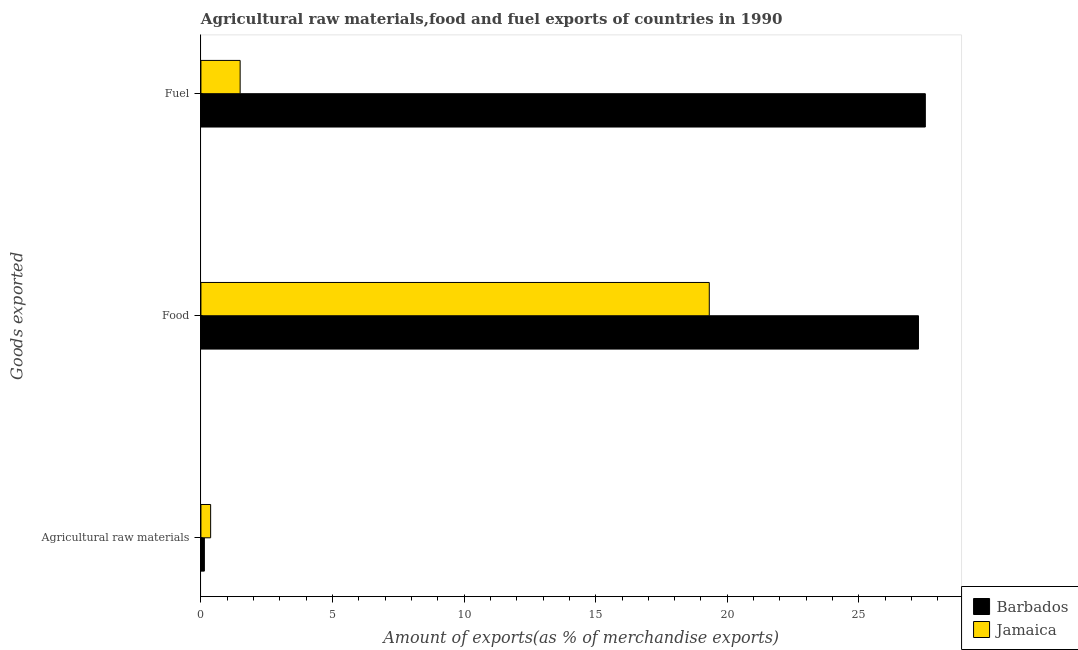How many different coloured bars are there?
Provide a short and direct response. 2. Are the number of bars per tick equal to the number of legend labels?
Ensure brevity in your answer.  Yes. What is the label of the 1st group of bars from the top?
Your response must be concise. Fuel. What is the percentage of raw materials exports in Barbados?
Provide a short and direct response. 0.13. Across all countries, what is the maximum percentage of raw materials exports?
Your response must be concise. 0.37. Across all countries, what is the minimum percentage of food exports?
Provide a short and direct response. 19.32. In which country was the percentage of raw materials exports maximum?
Give a very brief answer. Jamaica. In which country was the percentage of food exports minimum?
Provide a succinct answer. Jamaica. What is the total percentage of fuel exports in the graph?
Keep it short and to the point. 29.02. What is the difference between the percentage of fuel exports in Barbados and that in Jamaica?
Provide a succinct answer. 26.03. What is the difference between the percentage of fuel exports in Barbados and the percentage of food exports in Jamaica?
Provide a succinct answer. 8.21. What is the average percentage of fuel exports per country?
Provide a succinct answer. 14.51. What is the difference between the percentage of fuel exports and percentage of raw materials exports in Barbados?
Make the answer very short. 27.39. What is the ratio of the percentage of fuel exports in Jamaica to that in Barbados?
Offer a terse response. 0.05. Is the difference between the percentage of food exports in Barbados and Jamaica greater than the difference between the percentage of raw materials exports in Barbados and Jamaica?
Provide a short and direct response. Yes. What is the difference between the highest and the second highest percentage of food exports?
Provide a short and direct response. 7.95. What is the difference between the highest and the lowest percentage of food exports?
Your answer should be compact. 7.95. In how many countries, is the percentage of raw materials exports greater than the average percentage of raw materials exports taken over all countries?
Make the answer very short. 1. What does the 1st bar from the top in Food represents?
Make the answer very short. Jamaica. What does the 1st bar from the bottom in Agricultural raw materials represents?
Ensure brevity in your answer.  Barbados. Is it the case that in every country, the sum of the percentage of raw materials exports and percentage of food exports is greater than the percentage of fuel exports?
Give a very brief answer. No. Are all the bars in the graph horizontal?
Your answer should be very brief. Yes. Does the graph contain any zero values?
Your answer should be compact. No. Where does the legend appear in the graph?
Give a very brief answer. Bottom right. What is the title of the graph?
Provide a succinct answer. Agricultural raw materials,food and fuel exports of countries in 1990. Does "Ireland" appear as one of the legend labels in the graph?
Keep it short and to the point. No. What is the label or title of the X-axis?
Provide a short and direct response. Amount of exports(as % of merchandise exports). What is the label or title of the Y-axis?
Make the answer very short. Goods exported. What is the Amount of exports(as % of merchandise exports) in Barbados in Agricultural raw materials?
Give a very brief answer. 0.13. What is the Amount of exports(as % of merchandise exports) of Jamaica in Agricultural raw materials?
Ensure brevity in your answer.  0.37. What is the Amount of exports(as % of merchandise exports) in Barbados in Food?
Offer a very short reply. 27.26. What is the Amount of exports(as % of merchandise exports) in Jamaica in Food?
Offer a very short reply. 19.32. What is the Amount of exports(as % of merchandise exports) of Barbados in Fuel?
Keep it short and to the point. 27.52. What is the Amount of exports(as % of merchandise exports) of Jamaica in Fuel?
Your response must be concise. 1.49. Across all Goods exported, what is the maximum Amount of exports(as % of merchandise exports) of Barbados?
Provide a succinct answer. 27.52. Across all Goods exported, what is the maximum Amount of exports(as % of merchandise exports) of Jamaica?
Your response must be concise. 19.32. Across all Goods exported, what is the minimum Amount of exports(as % of merchandise exports) in Barbados?
Offer a very short reply. 0.13. Across all Goods exported, what is the minimum Amount of exports(as % of merchandise exports) in Jamaica?
Offer a very short reply. 0.37. What is the total Amount of exports(as % of merchandise exports) of Barbados in the graph?
Your answer should be compact. 54.92. What is the total Amount of exports(as % of merchandise exports) in Jamaica in the graph?
Give a very brief answer. 21.18. What is the difference between the Amount of exports(as % of merchandise exports) of Barbados in Agricultural raw materials and that in Food?
Provide a short and direct response. -27.13. What is the difference between the Amount of exports(as % of merchandise exports) of Jamaica in Agricultural raw materials and that in Food?
Keep it short and to the point. -18.95. What is the difference between the Amount of exports(as % of merchandise exports) of Barbados in Agricultural raw materials and that in Fuel?
Keep it short and to the point. -27.39. What is the difference between the Amount of exports(as % of merchandise exports) in Jamaica in Agricultural raw materials and that in Fuel?
Offer a terse response. -1.12. What is the difference between the Amount of exports(as % of merchandise exports) of Barbados in Food and that in Fuel?
Provide a succinct answer. -0.26. What is the difference between the Amount of exports(as % of merchandise exports) of Jamaica in Food and that in Fuel?
Your answer should be very brief. 17.82. What is the difference between the Amount of exports(as % of merchandise exports) of Barbados in Agricultural raw materials and the Amount of exports(as % of merchandise exports) of Jamaica in Food?
Your response must be concise. -19.18. What is the difference between the Amount of exports(as % of merchandise exports) of Barbados in Agricultural raw materials and the Amount of exports(as % of merchandise exports) of Jamaica in Fuel?
Keep it short and to the point. -1.36. What is the difference between the Amount of exports(as % of merchandise exports) in Barbados in Food and the Amount of exports(as % of merchandise exports) in Jamaica in Fuel?
Offer a very short reply. 25.77. What is the average Amount of exports(as % of merchandise exports) in Barbados per Goods exported?
Ensure brevity in your answer.  18.31. What is the average Amount of exports(as % of merchandise exports) of Jamaica per Goods exported?
Keep it short and to the point. 7.06. What is the difference between the Amount of exports(as % of merchandise exports) in Barbados and Amount of exports(as % of merchandise exports) in Jamaica in Agricultural raw materials?
Offer a very short reply. -0.24. What is the difference between the Amount of exports(as % of merchandise exports) in Barbados and Amount of exports(as % of merchandise exports) in Jamaica in Food?
Provide a succinct answer. 7.95. What is the difference between the Amount of exports(as % of merchandise exports) of Barbados and Amount of exports(as % of merchandise exports) of Jamaica in Fuel?
Provide a short and direct response. 26.03. What is the ratio of the Amount of exports(as % of merchandise exports) in Barbados in Agricultural raw materials to that in Food?
Ensure brevity in your answer.  0. What is the ratio of the Amount of exports(as % of merchandise exports) in Jamaica in Agricultural raw materials to that in Food?
Ensure brevity in your answer.  0.02. What is the ratio of the Amount of exports(as % of merchandise exports) in Barbados in Agricultural raw materials to that in Fuel?
Offer a terse response. 0. What is the ratio of the Amount of exports(as % of merchandise exports) of Jamaica in Agricultural raw materials to that in Fuel?
Provide a short and direct response. 0.25. What is the ratio of the Amount of exports(as % of merchandise exports) of Jamaica in Food to that in Fuel?
Provide a succinct answer. 12.96. What is the difference between the highest and the second highest Amount of exports(as % of merchandise exports) in Barbados?
Provide a succinct answer. 0.26. What is the difference between the highest and the second highest Amount of exports(as % of merchandise exports) of Jamaica?
Provide a short and direct response. 17.82. What is the difference between the highest and the lowest Amount of exports(as % of merchandise exports) in Barbados?
Make the answer very short. 27.39. What is the difference between the highest and the lowest Amount of exports(as % of merchandise exports) in Jamaica?
Provide a succinct answer. 18.95. 